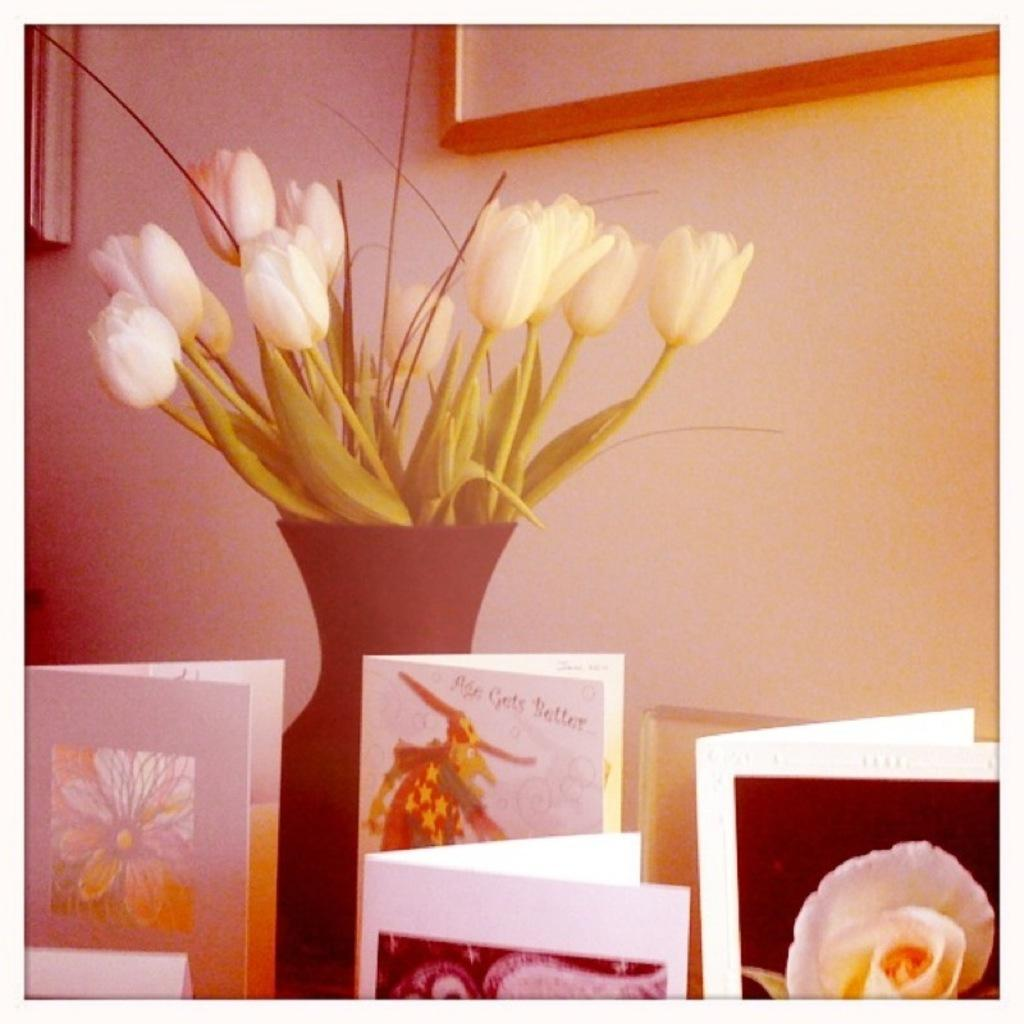What is in the vase that is visible in the image? There are flowers in a vase in the image. What objects are in the foreground of the image? There are cards in the foreground of the image. What can be seen on the wall in the background of the image? There are photo frames on the wall in the background of the image. How many dimes are scattered on the hill in the image? There is no hill or dimes present in the image. What scientific experiment is being conducted in the image? There is no scientific experiment being conducted in the image. 